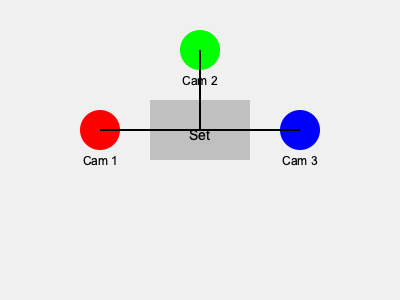In a typical Spanish talk show studio setup, which camera angle would be best suited for capturing a wide shot of the entire set and all participants? To determine the best camera angle for a wide shot of the entire set and all participants in a Spanish talk show studio setup, let's analyze the diagram:

1. Camera 1 (Red): Located on the left side of the set. This camera provides a side angle view, which is not ideal for capturing the entire set and all participants.

2. Camera 2 (Green): Positioned above the set. This camera offers a high angle or "bird's eye" view of the set. While it can capture the entire set, it may not provide the most flattering or conventional angle for a talk show.

3. Camera 3 (Blue): Situated on the right side of the set. Similar to Camera 1, this camera provides a side angle view, which is not optimal for capturing the entire set and all participants.

4. Central position: Notice that Camera 2 is positioned directly above the center of the set. This central position is key for capturing a wide shot.

5. Angle consideration: For a wide shot that includes the entire set and all participants, we need a camera that can capture the scene from a frontal perspective, providing depth and context.

6. Industry standard: In television production, the "master shot" or wide shot is typically captured from a camera positioned at the center, slightly elevated, and at a distance from the set.

Considering these factors, the best solution would be to use Camera 2, but lowered and moved back from its current position. This would provide a central, slightly elevated angle that can capture the entire set and all participants in a wide shot.

However, since we are limited to the three cameras shown in the diagram, Camera 2 remains the best option among the available choices. Its central position allows for the most comprehensive view of the set, even if the angle is higher than ideal.
Answer: Camera 2 